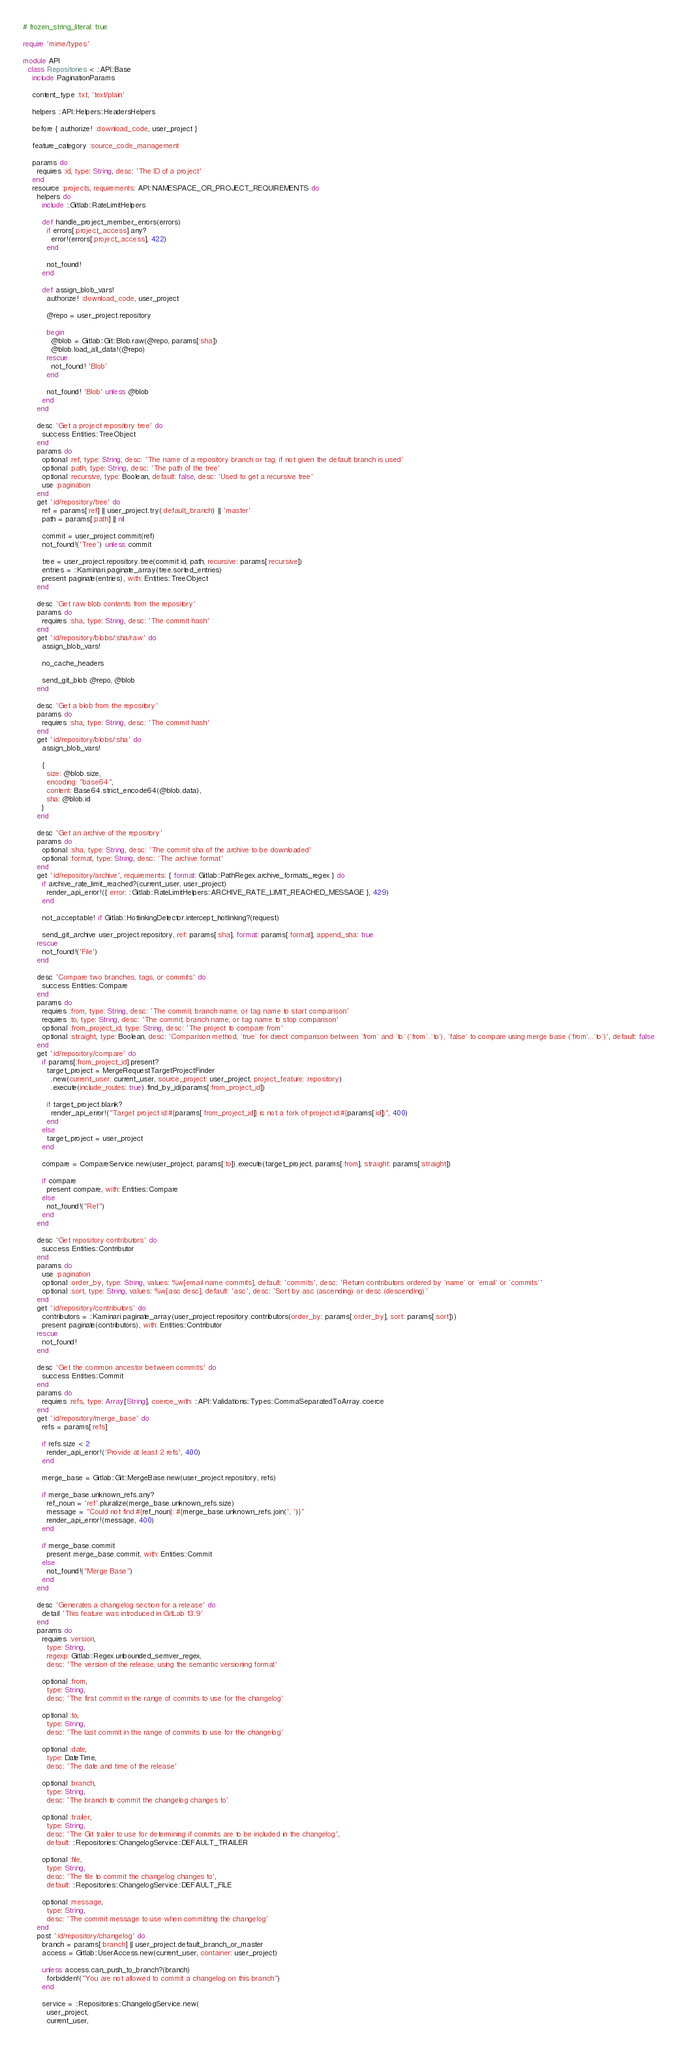<code> <loc_0><loc_0><loc_500><loc_500><_Ruby_># frozen_string_literal: true

require 'mime/types'

module API
  class Repositories < ::API::Base
    include PaginationParams

    content_type :txt, 'text/plain'

    helpers ::API::Helpers::HeadersHelpers

    before { authorize! :download_code, user_project }

    feature_category :source_code_management

    params do
      requires :id, type: String, desc: 'The ID of a project'
    end
    resource :projects, requirements: API::NAMESPACE_OR_PROJECT_REQUIREMENTS do
      helpers do
        include ::Gitlab::RateLimitHelpers

        def handle_project_member_errors(errors)
          if errors[:project_access].any?
            error!(errors[:project_access], 422)
          end

          not_found!
        end

        def assign_blob_vars!
          authorize! :download_code, user_project

          @repo = user_project.repository

          begin
            @blob = Gitlab::Git::Blob.raw(@repo, params[:sha])
            @blob.load_all_data!(@repo)
          rescue
            not_found! 'Blob'
          end

          not_found! 'Blob' unless @blob
        end
      end

      desc 'Get a project repository tree' do
        success Entities::TreeObject
      end
      params do
        optional :ref, type: String, desc: 'The name of a repository branch or tag, if not given the default branch is used'
        optional :path, type: String, desc: 'The path of the tree'
        optional :recursive, type: Boolean, default: false, desc: 'Used to get a recursive tree'
        use :pagination
      end
      get ':id/repository/tree' do
        ref = params[:ref] || user_project.try(:default_branch) || 'master'
        path = params[:path] || nil

        commit = user_project.commit(ref)
        not_found!('Tree') unless commit

        tree = user_project.repository.tree(commit.id, path, recursive: params[:recursive])
        entries = ::Kaminari.paginate_array(tree.sorted_entries)
        present paginate(entries), with: Entities::TreeObject
      end

      desc 'Get raw blob contents from the repository'
      params do
        requires :sha, type: String, desc: 'The commit hash'
      end
      get ':id/repository/blobs/:sha/raw' do
        assign_blob_vars!

        no_cache_headers

        send_git_blob @repo, @blob
      end

      desc 'Get a blob from the repository'
      params do
        requires :sha, type: String, desc: 'The commit hash'
      end
      get ':id/repository/blobs/:sha' do
        assign_blob_vars!

        {
          size: @blob.size,
          encoding: "base64",
          content: Base64.strict_encode64(@blob.data),
          sha: @blob.id
        }
      end

      desc 'Get an archive of the repository'
      params do
        optional :sha, type: String, desc: 'The commit sha of the archive to be downloaded'
        optional :format, type: String, desc: 'The archive format'
      end
      get ':id/repository/archive', requirements: { format: Gitlab::PathRegex.archive_formats_regex } do
        if archive_rate_limit_reached?(current_user, user_project)
          render_api_error!({ error: ::Gitlab::RateLimitHelpers::ARCHIVE_RATE_LIMIT_REACHED_MESSAGE }, 429)
        end

        not_acceptable! if Gitlab::HotlinkingDetector.intercept_hotlinking?(request)

        send_git_archive user_project.repository, ref: params[:sha], format: params[:format], append_sha: true
      rescue
        not_found!('File')
      end

      desc 'Compare two branches, tags, or commits' do
        success Entities::Compare
      end
      params do
        requires :from, type: String, desc: 'The commit, branch name, or tag name to start comparison'
        requires :to, type: String, desc: 'The commit, branch name, or tag name to stop comparison'
        optional :from_project_id, type: String, desc: 'The project to compare from'
        optional :straight, type: Boolean, desc: 'Comparison method, `true` for direct comparison between `from` and `to` (`from`..`to`), `false` to compare using merge base (`from`...`to`)', default: false
      end
      get ':id/repository/compare' do
        if params[:from_project_id].present?
          target_project = MergeRequestTargetProjectFinder
            .new(current_user: current_user, source_project: user_project, project_feature: :repository)
            .execute(include_routes: true).find_by_id(params[:from_project_id])

          if target_project.blank?
            render_api_error!("Target project id:#{params[:from_project_id]} is not a fork of project id:#{params[:id]}", 400)
          end
        else
          target_project = user_project
        end

        compare = CompareService.new(user_project, params[:to]).execute(target_project, params[:from], straight: params[:straight])

        if compare
          present compare, with: Entities::Compare
        else
          not_found!("Ref")
        end
      end

      desc 'Get repository contributors' do
        success Entities::Contributor
      end
      params do
        use :pagination
        optional :order_by, type: String, values: %w[email name commits], default: 'commits', desc: 'Return contributors ordered by `name` or `email` or `commits`'
        optional :sort, type: String, values: %w[asc desc], default: 'asc', desc: 'Sort by asc (ascending) or desc (descending)'
      end
      get ':id/repository/contributors' do
        contributors = ::Kaminari.paginate_array(user_project.repository.contributors(order_by: params[:order_by], sort: params[:sort]))
        present paginate(contributors), with: Entities::Contributor
      rescue
        not_found!
      end

      desc 'Get the common ancestor between commits' do
        success Entities::Commit
      end
      params do
        requires :refs, type: Array[String], coerce_with: ::API::Validations::Types::CommaSeparatedToArray.coerce
      end
      get ':id/repository/merge_base' do
        refs = params[:refs]

        if refs.size < 2
          render_api_error!('Provide at least 2 refs', 400)
        end

        merge_base = Gitlab::Git::MergeBase.new(user_project.repository, refs)

        if merge_base.unknown_refs.any?
          ref_noun = 'ref'.pluralize(merge_base.unknown_refs.size)
          message = "Could not find #{ref_noun}: #{merge_base.unknown_refs.join(', ')}"
          render_api_error!(message, 400)
        end

        if merge_base.commit
          present merge_base.commit, with: Entities::Commit
        else
          not_found!("Merge Base")
        end
      end

      desc 'Generates a changelog section for a release' do
        detail 'This feature was introduced in GitLab 13.9'
      end
      params do
        requires :version,
          type: String,
          regexp: Gitlab::Regex.unbounded_semver_regex,
          desc: 'The version of the release, using the semantic versioning format'

        optional :from,
          type: String,
          desc: 'The first commit in the range of commits to use for the changelog'

        optional :to,
          type: String,
          desc: 'The last commit in the range of commits to use for the changelog'

        optional :date,
          type: DateTime,
          desc: 'The date and time of the release'

        optional :branch,
          type: String,
          desc: 'The branch to commit the changelog changes to'

        optional :trailer,
          type: String,
          desc: 'The Git trailer to use for determining if commits are to be included in the changelog',
          default: ::Repositories::ChangelogService::DEFAULT_TRAILER

        optional :file,
          type: String,
          desc: 'The file to commit the changelog changes to',
          default: ::Repositories::ChangelogService::DEFAULT_FILE

        optional :message,
          type: String,
          desc: 'The commit message to use when committing the changelog'
      end
      post ':id/repository/changelog' do
        branch = params[:branch] || user_project.default_branch_or_master
        access = Gitlab::UserAccess.new(current_user, container: user_project)

        unless access.can_push_to_branch?(branch)
          forbidden!("You are not allowed to commit a changelog on this branch")
        end

        service = ::Repositories::ChangelogService.new(
          user_project,
          current_user,</code> 